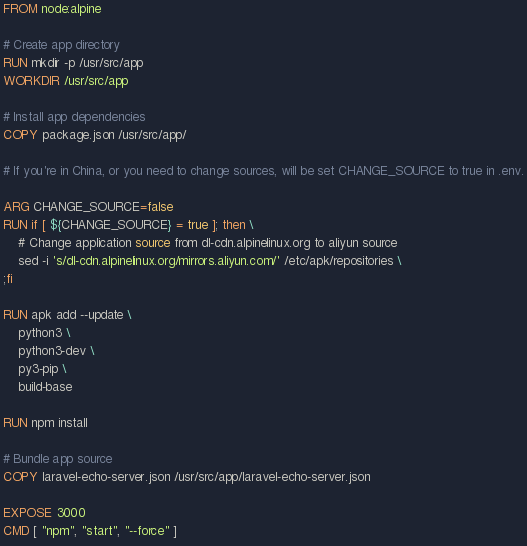Convert code to text. <code><loc_0><loc_0><loc_500><loc_500><_Dockerfile_>FROM node:alpine

# Create app directory
RUN mkdir -p /usr/src/app
WORKDIR /usr/src/app

# Install app dependencies
COPY package.json /usr/src/app/

# If you're in China, or you need to change sources, will be set CHANGE_SOURCE to true in .env.

ARG CHANGE_SOURCE=false
RUN if [ ${CHANGE_SOURCE} = true ]; then \
    # Change application source from dl-cdn.alpinelinux.org to aliyun source
    sed -i 's/dl-cdn.alpinelinux.org/mirrors.aliyun.com/' /etc/apk/repositories \
;fi

RUN apk add --update \
    python3 \
    python3-dev \
    py3-pip \
    build-base

RUN npm install

# Bundle app source
COPY laravel-echo-server.json /usr/src/app/laravel-echo-server.json

EXPOSE 3000
CMD [ "npm", "start", "--force" ]
</code> 